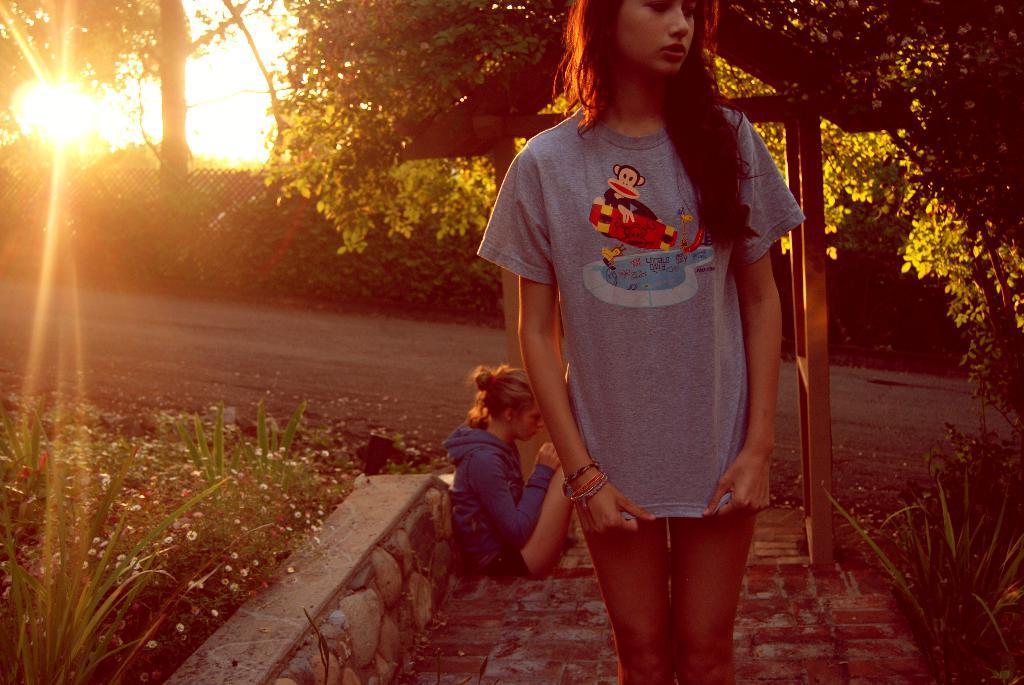In one or two sentences, can you explain what this image depicts? Here we can see two people. One woman is standing and another woman is sitting. Beside these people there are plants with flowers. Background there are trees and mesh. Far there is a sunrise. 